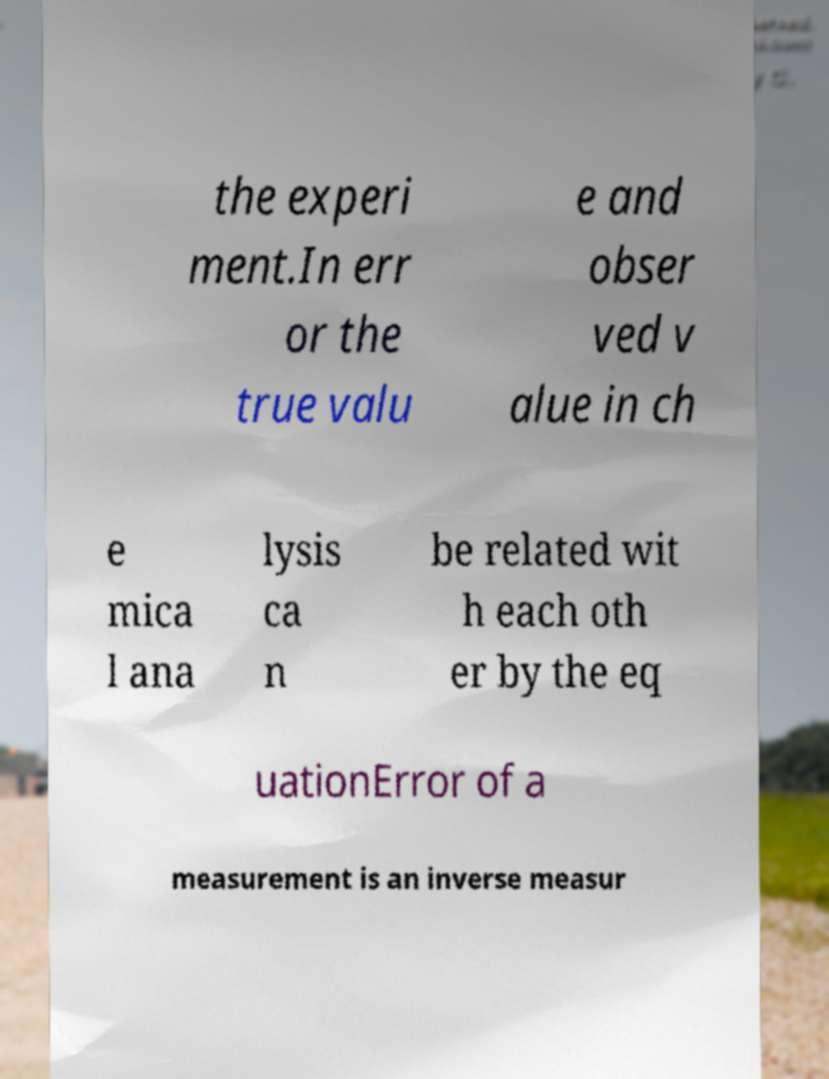Can you read and provide the text displayed in the image?This photo seems to have some interesting text. Can you extract and type it out for me? the experi ment.In err or the true valu e and obser ved v alue in ch e mica l ana lysis ca n be related wit h each oth er by the eq uationError of a measurement is an inverse measur 